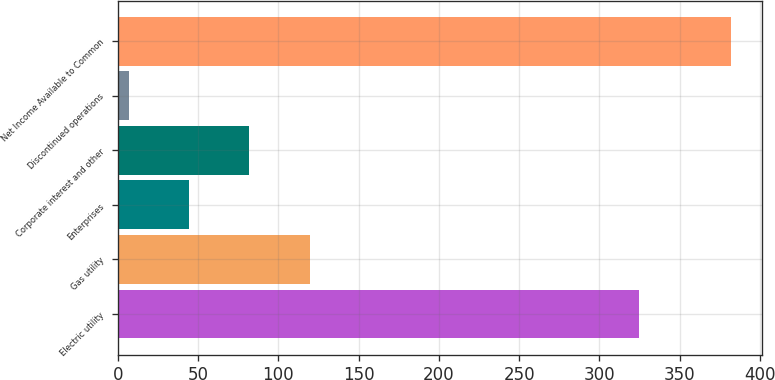<chart> <loc_0><loc_0><loc_500><loc_500><bar_chart><fcel>Electric utility<fcel>Gas utility<fcel>Enterprises<fcel>Corporate interest and other<fcel>Discontinued operations<fcel>Net Income Available to Common<nl><fcel>325<fcel>119.5<fcel>44.5<fcel>82<fcel>7<fcel>382<nl></chart> 